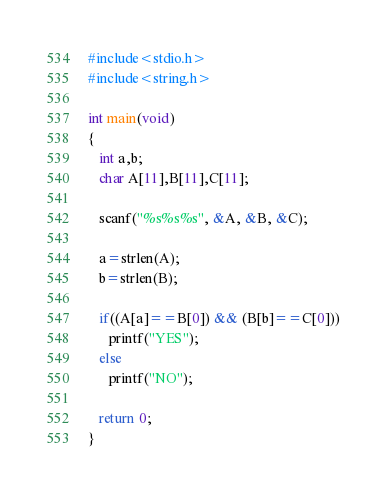<code> <loc_0><loc_0><loc_500><loc_500><_C_>#include<stdio.h>
#include<string.h>

int main(void)
{
   int a,b;
   char A[11],B[11],C[11];

   scanf("%s%s%s", &A, &B, &C);

   a=strlen(A);
   b=strlen(B);

   if((A[a]==B[0]) && (B[b]==C[0]))
      printf("YES");
   else
      printf("NO");

   return 0;
}
</code> 